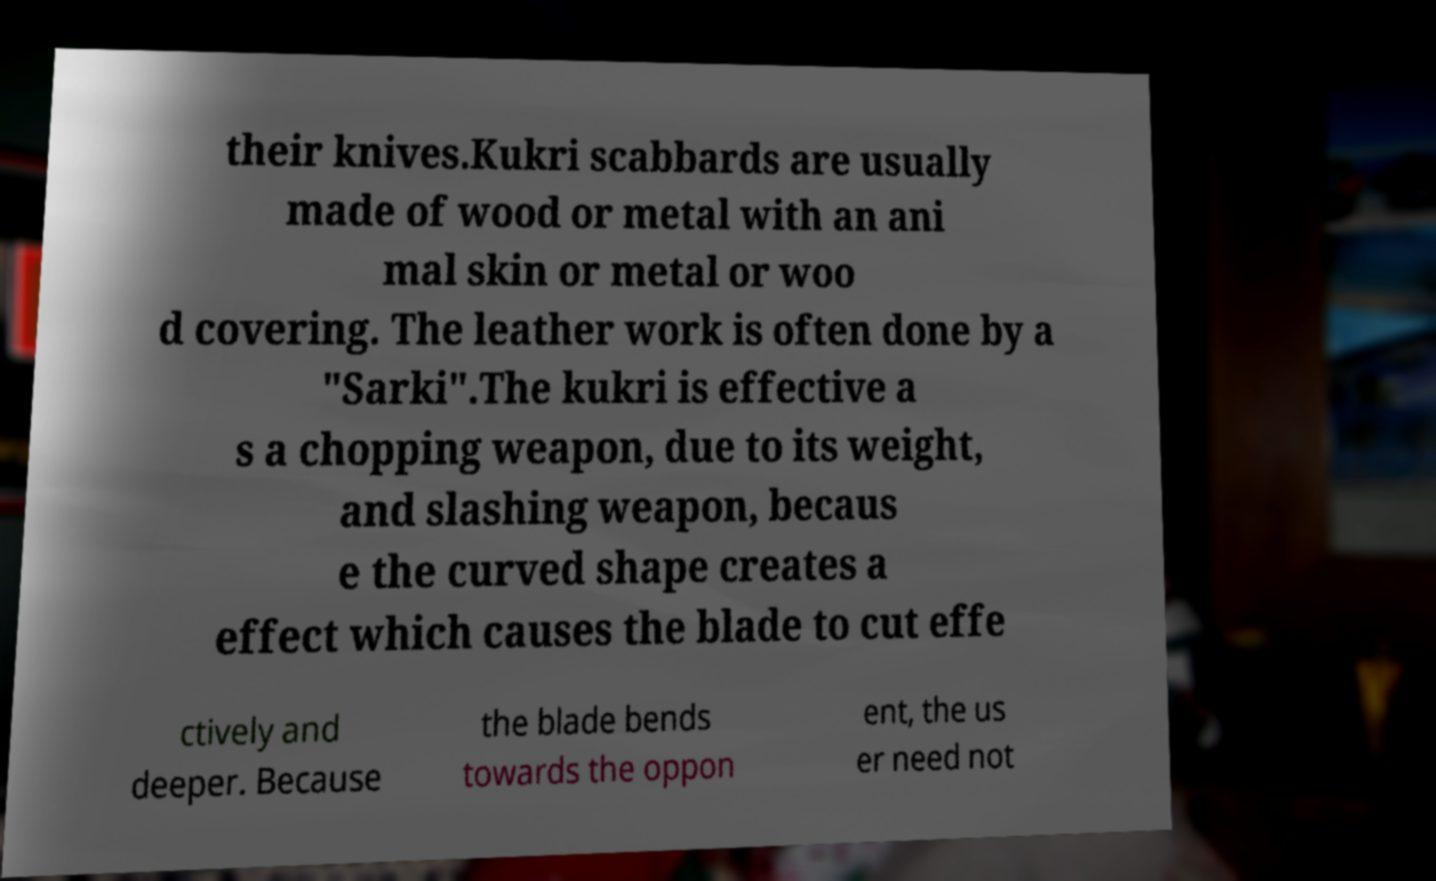I need the written content from this picture converted into text. Can you do that? their knives.Kukri scabbards are usually made of wood or metal with an ani mal skin or metal or woo d covering. The leather work is often done by a "Sarki".The kukri is effective a s a chopping weapon, due to its weight, and slashing weapon, becaus e the curved shape creates a effect which causes the blade to cut effe ctively and deeper. Because the blade bends towards the oppon ent, the us er need not 